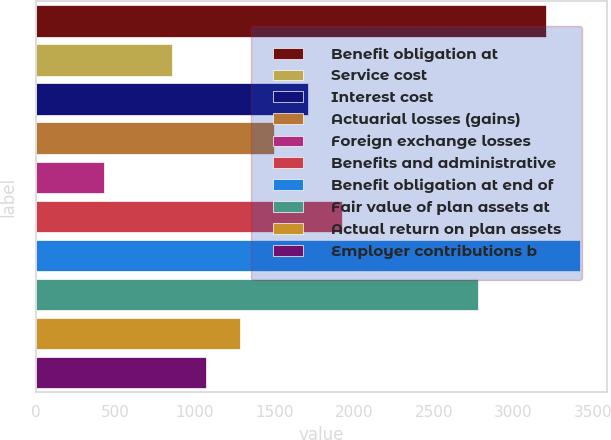Convert chart. <chart><loc_0><loc_0><loc_500><loc_500><bar_chart><fcel>Benefit obligation at<fcel>Service cost<fcel>Interest cost<fcel>Actuarial losses (gains)<fcel>Foreign exchange losses<fcel>Benefits and administrative<fcel>Benefit obligation at end of<fcel>Fair value of plan assets at<fcel>Actual return on plan assets<fcel>Employer contributions b<nl><fcel>3201<fcel>855.8<fcel>1708.6<fcel>1495.4<fcel>429.4<fcel>1921.8<fcel>3414.2<fcel>2774.6<fcel>1282.2<fcel>1069<nl></chart> 